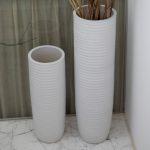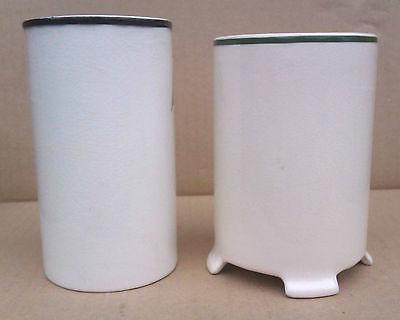The first image is the image on the left, the second image is the image on the right. For the images shown, is this caption "One image has two vases of equal height." true? Answer yes or no. No. The first image is the image on the left, the second image is the image on the right. Assess this claim about the two images: "there are no more than 3 vases in an image pair". Correct or not? Answer yes or no. No. 